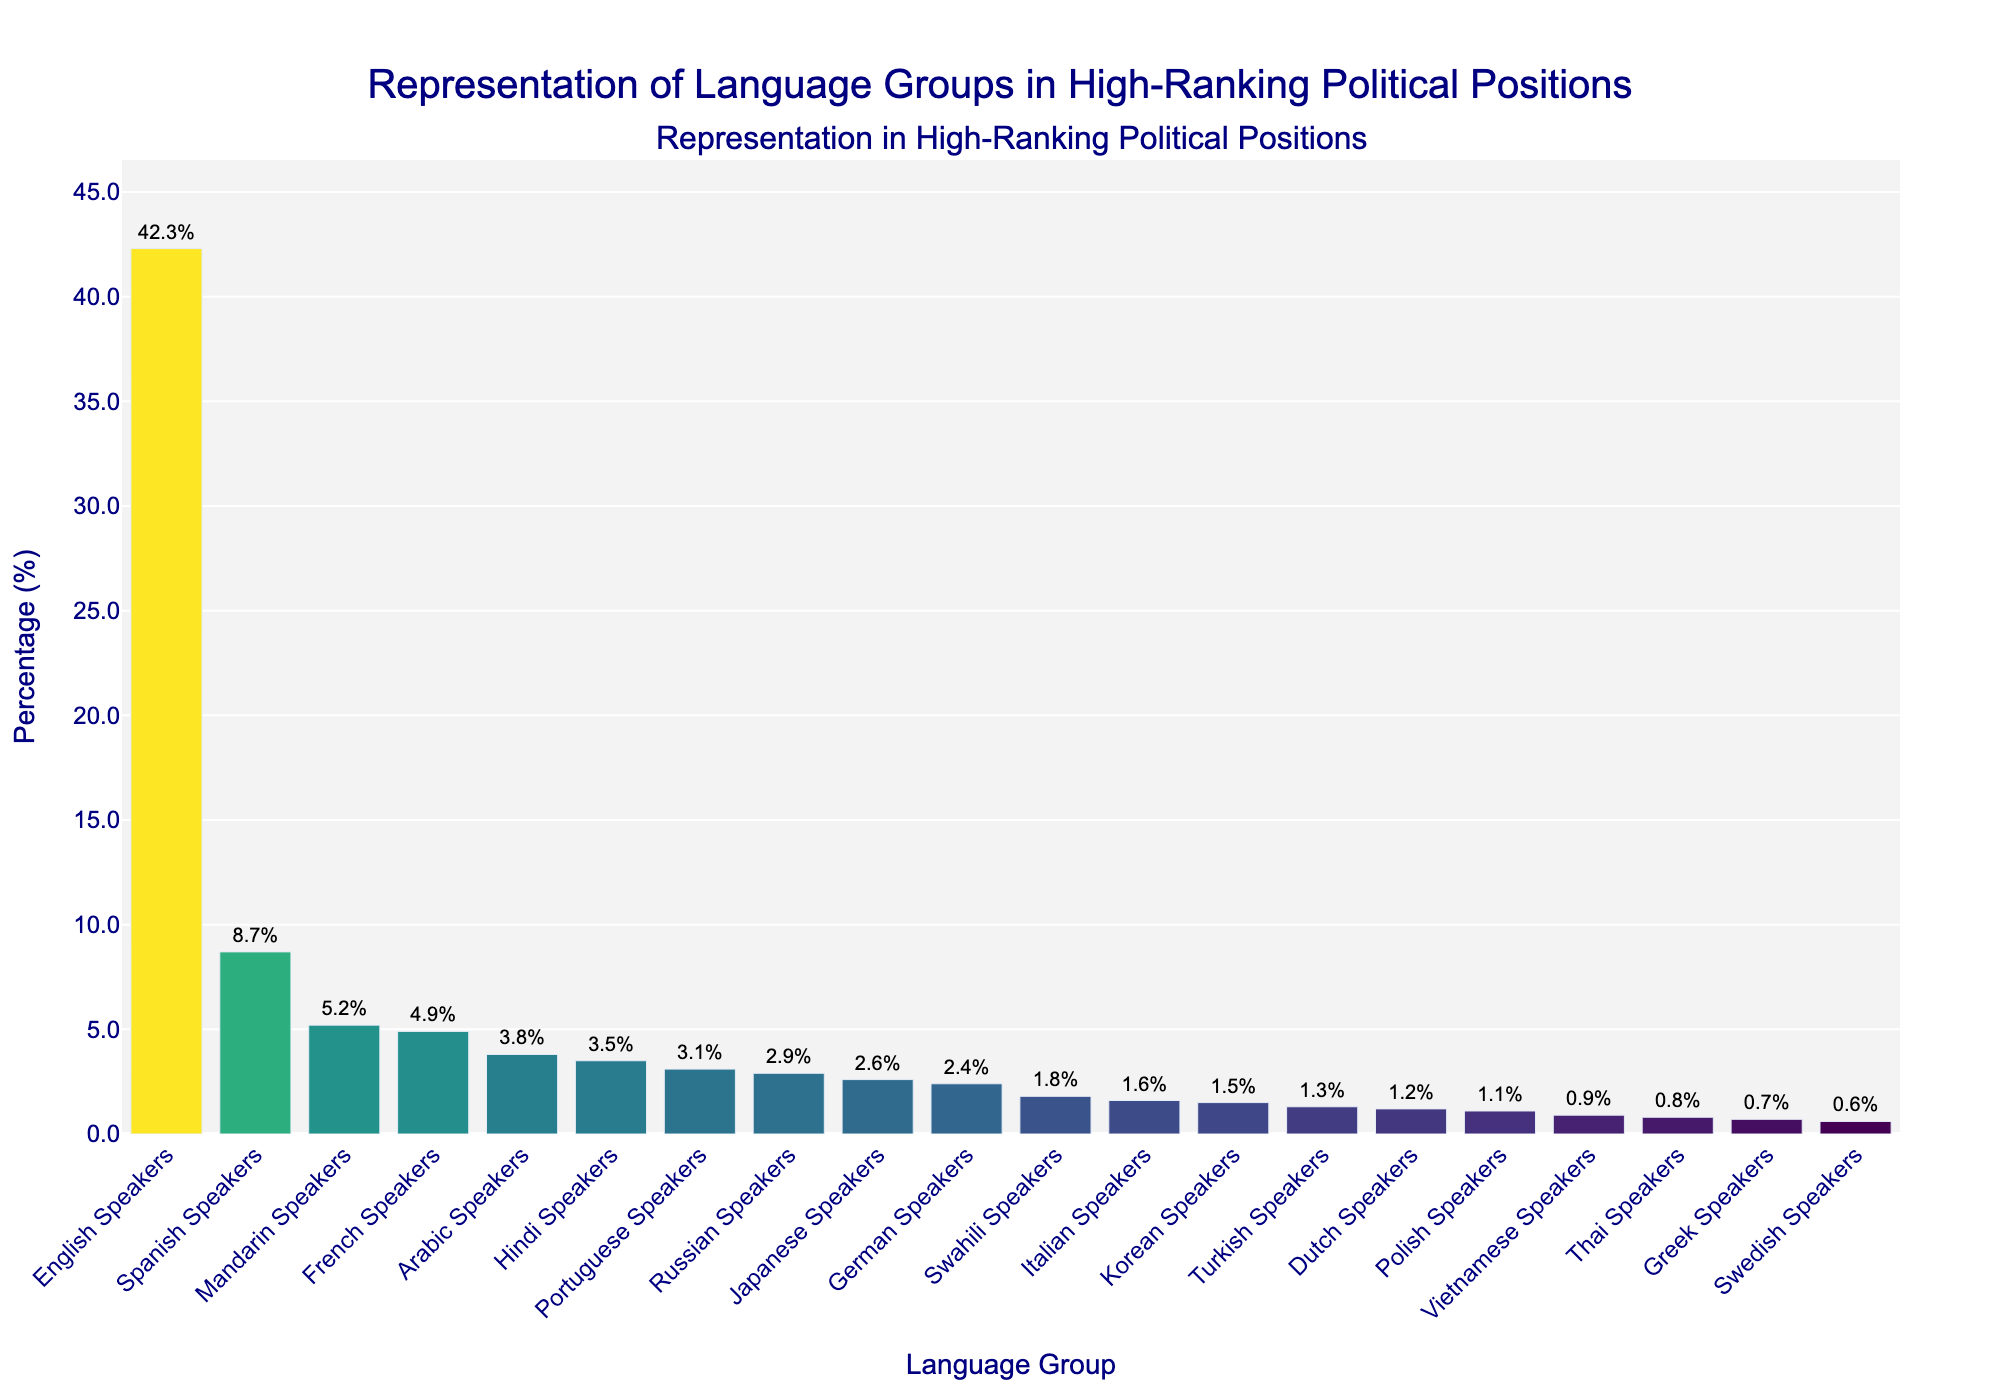Which language group has the highest representation in high-ranking political positions? By looking at the bar chart, we can see the tallest bar represents the language group with the highest percentage. The tallest bar corresponds to English Speakers at 42.3%.
Answer: English Speakers Which language group has the lowest representation in high-ranking political positions? By identifying the shortest bar on the chart, we find it represents Swedish Speakers with a percentage of 0.6%.
Answer: Swedish Speakers What is the difference in representation between English Speakers and Spanish Speakers? The representation for English Speakers is 42.3% and for Spanish Speakers, it is 8.7%. Subtracting these gives us 42.3 - 8.7 = 33.6.
Answer: 33.6 What is the combined percentage of Mandarin, French, and Arabic Speakers? Adding the percentages of Mandarin Speakers (5.2%), French Speakers (4.9%), and Arabic Speakers (3.8%) gives the combined percentage as 5.2 + 4.9 + 3.8 = 13.9.
Answer: 13.9 Which group has a slightly higher representation: Hindi or Portuguese Speakers? Comparing the heights and percentages, Hindi Speakers have 3.5% and Portuguese Speakers have 3.1%, making Hindi Speakers slightly higher.
Answer: Hindi Speakers How many language groups have less than 2% representation? Identifying the bars with percentages less than 2%, we have Swahili, Italian, Korean, Turkish, Dutch, Polish, Vietnamese, Thai, Greek, and Swedish Speakers. There are 10 such groups.
Answer: 10 What is the average representation of the top five language groups? The top five language groups and their percentages are English Speakers (42.3%), Spanish Speakers (8.7%), Mandarin Speakers (5.2%), French Speakers (4.9%), and Arabic Speakers (3.8%). The average is calculated as (42.3 + 8.7 + 5.2 + 4.9 + 3.8) / 5 = 64.9 / 5 = 13.0.
Answer: 13.0 Which language group has a representation closest to 2.0%? The percentage closest to 2.0% is from German Speakers at 2.4%.
Answer: German Speakers Is the representation of Russian Speakers greater than that of Japanese Speakers? By comparing the percentages, Russian Speakers have 2.9% while Japanese Speakers have 2.6%. Therefore, Russian representation is greater.
Answer: Yes 